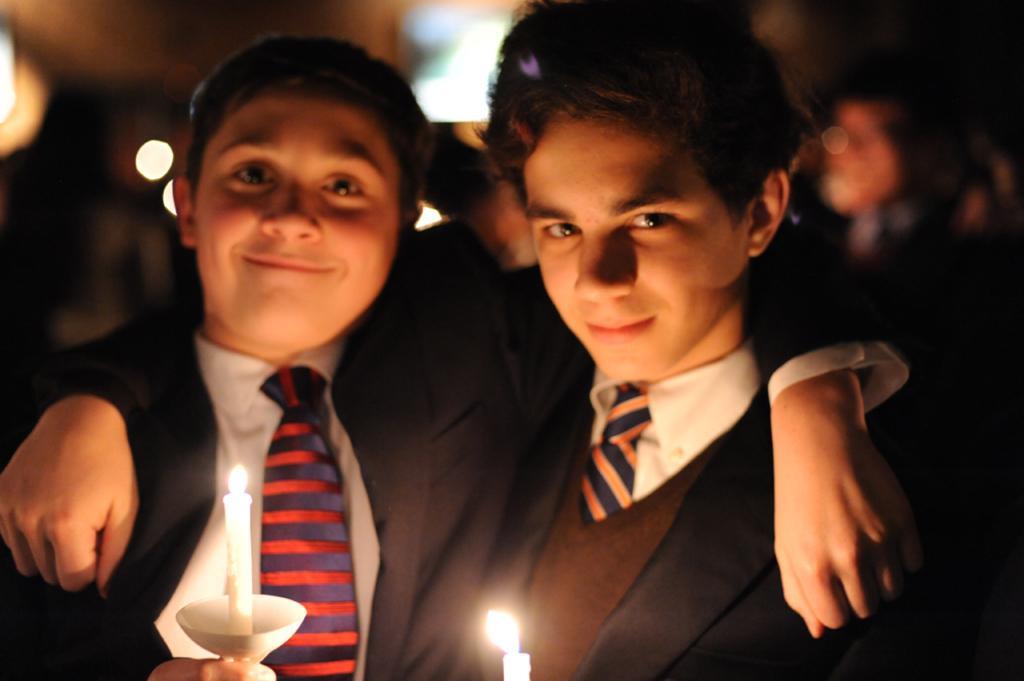How would you summarize this image in a sentence or two? In this image, we can see persons wearing clothes. There are candles at the bottom of the image. 